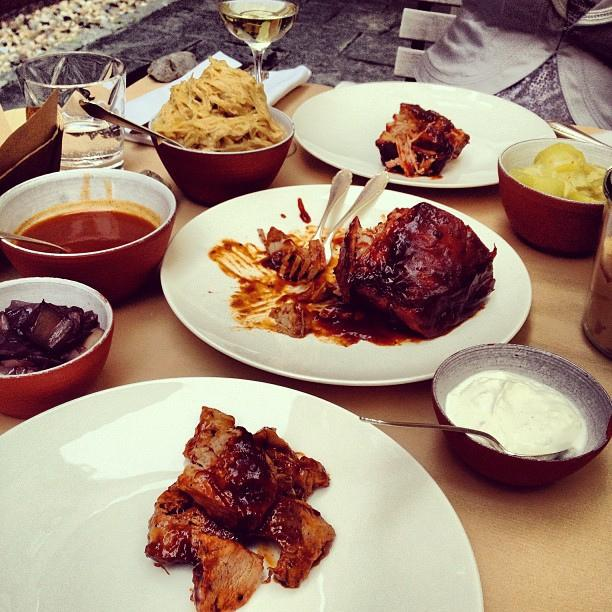What type feast is being served here? barbecue 